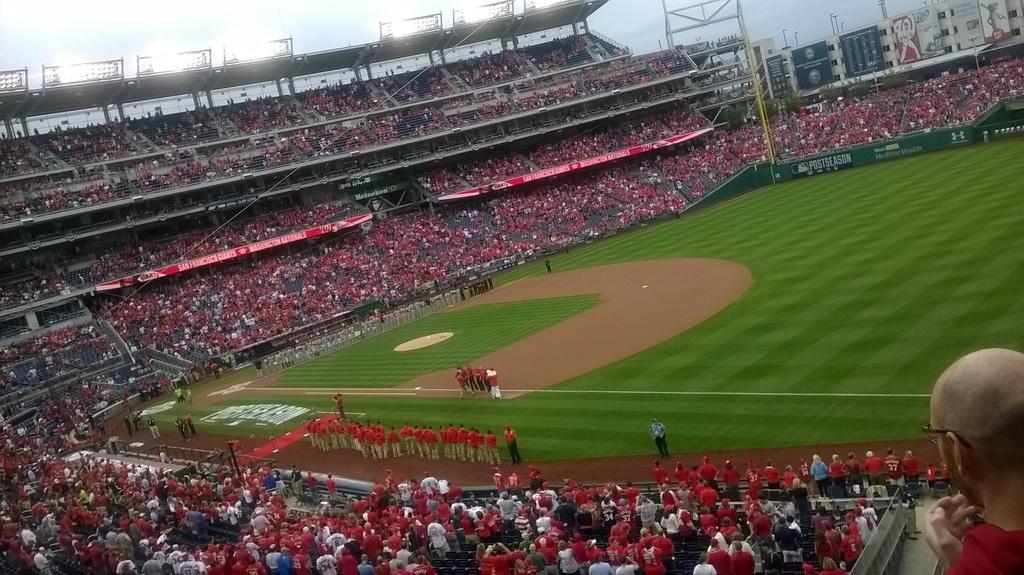Can you describe this image briefly? It is the ground in green color, many people are sitting and standing around this ground. 